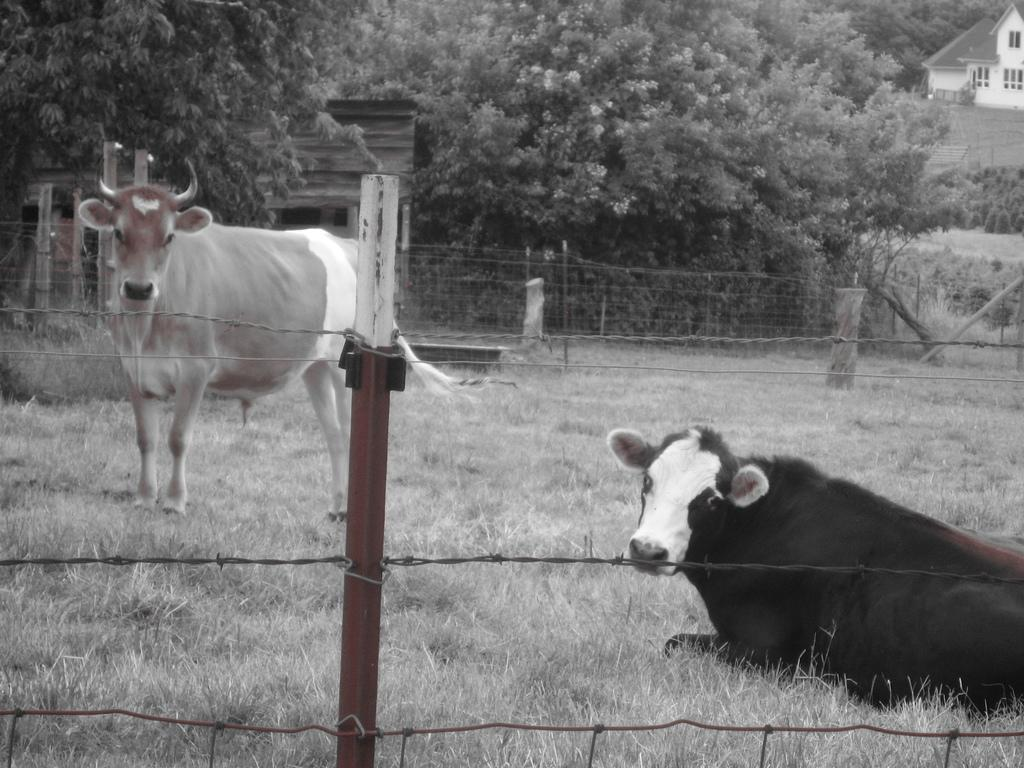What animals can be seen in the image? There are cows in the image. What type of vegetation is on the ground in the image? There is grass on the ground in the image. What type of fencing is present in the image? There is wire fencing with poles in the image. What can be seen in the background of the image? There are trees and buildings with windows in the background of the image. Where is the crown placed on the cow in the image? There is no crown present in the image; it only features cows, grass, wire fencing, trees, and buildings. 